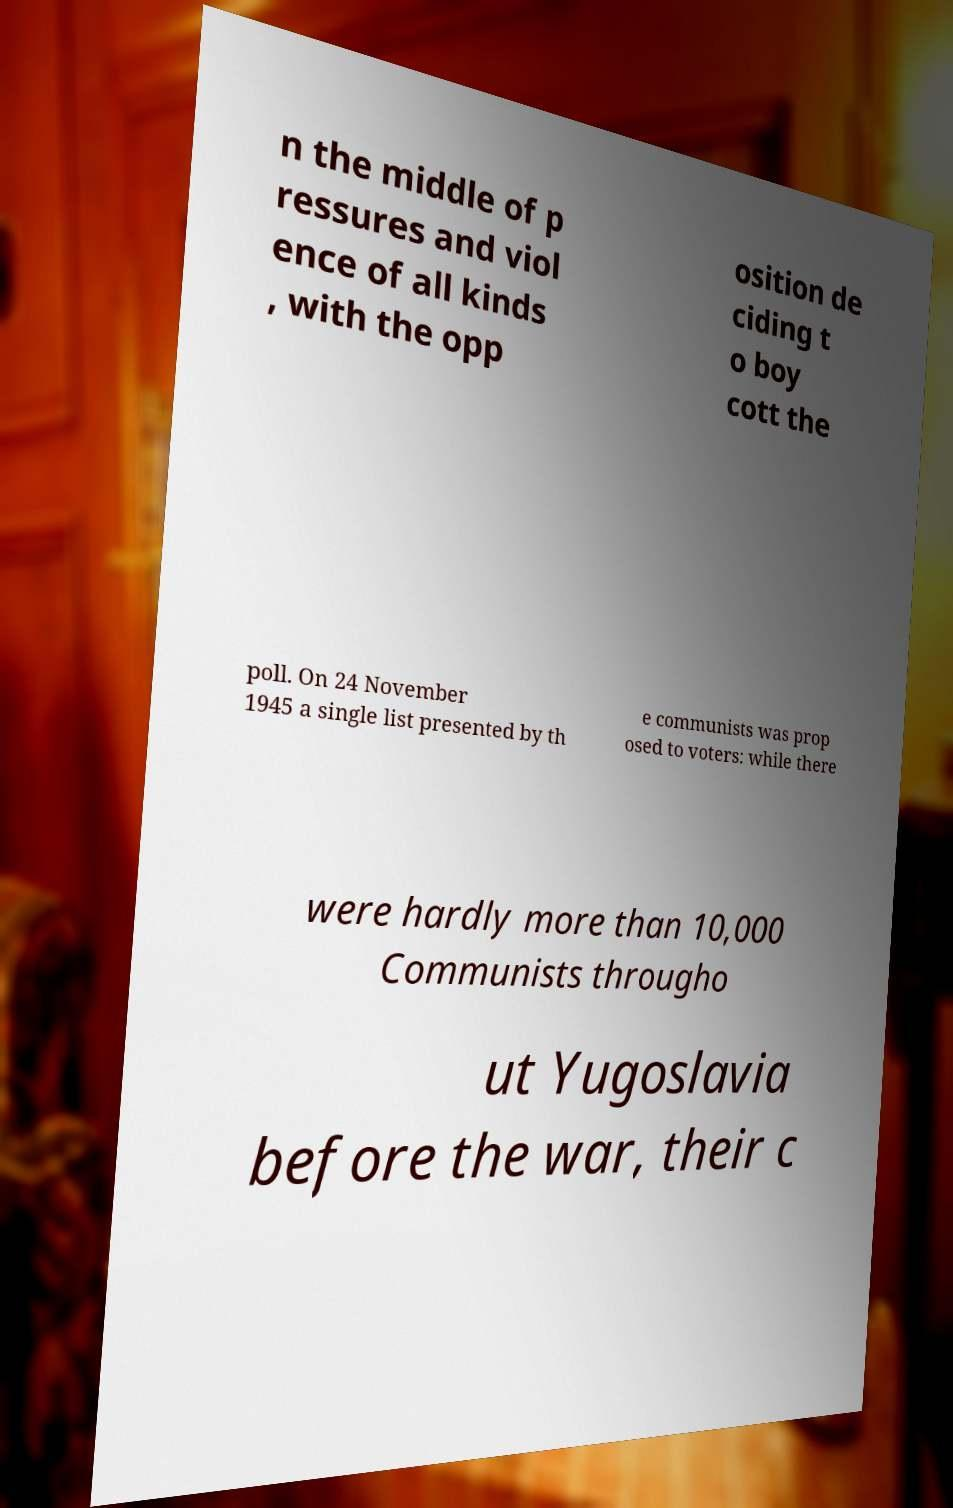Could you extract and type out the text from this image? n the middle of p ressures and viol ence of all kinds , with the opp osition de ciding t o boy cott the poll. On 24 November 1945 a single list presented by th e communists was prop osed to voters: while there were hardly more than 10,000 Communists througho ut Yugoslavia before the war, their c 